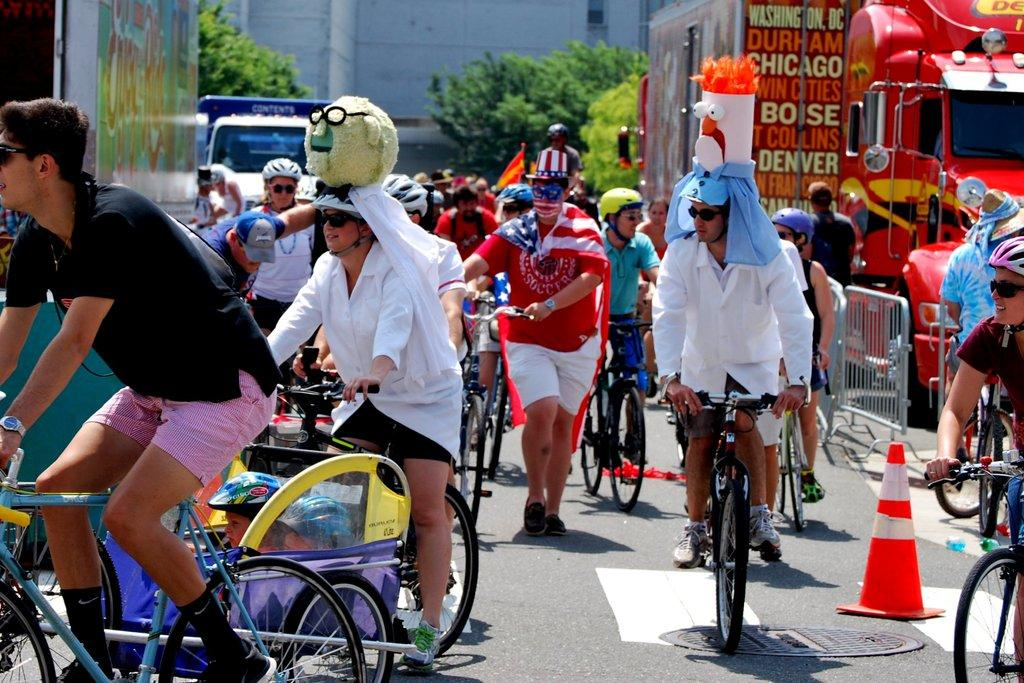What activity are the group of people engaged in on the road? The group of people are riding a cycle together on the road. What is the person walking with behind them? The person is walking with a circle behind them. What else can be seen on the road in the image? There are vehicles present in the image. What type of natural elements can be seen in the image? Trees are present in the image. What type of man-made structures can be seen in the image? There are buildings in the image. What type of eggnog is being served at the recess in the image? There is no recess or eggnog present in the image. What form does the circle behind the person walking take in the image? The circle behind the person walking is not described in detail, so it is not possible to determine its form from the image. 